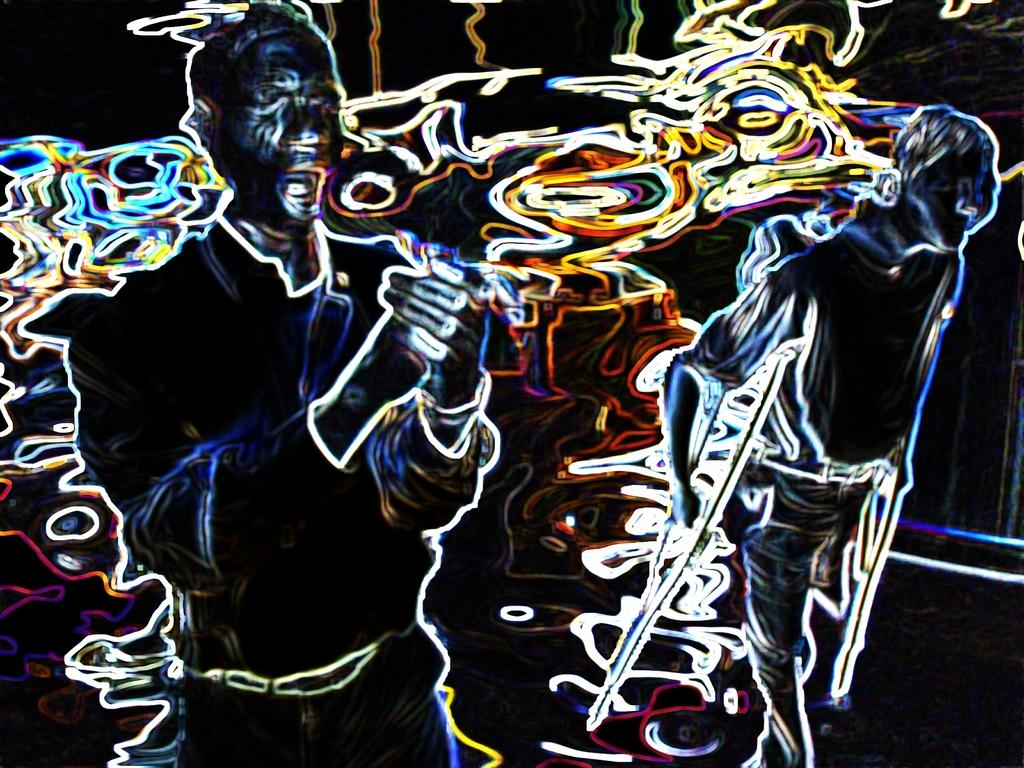What type of image is being described? The image is animated. What type of butter is being used in the animated image? There is no butter present in the image, as it is an animated image and not a still image of a scene involving butter. 